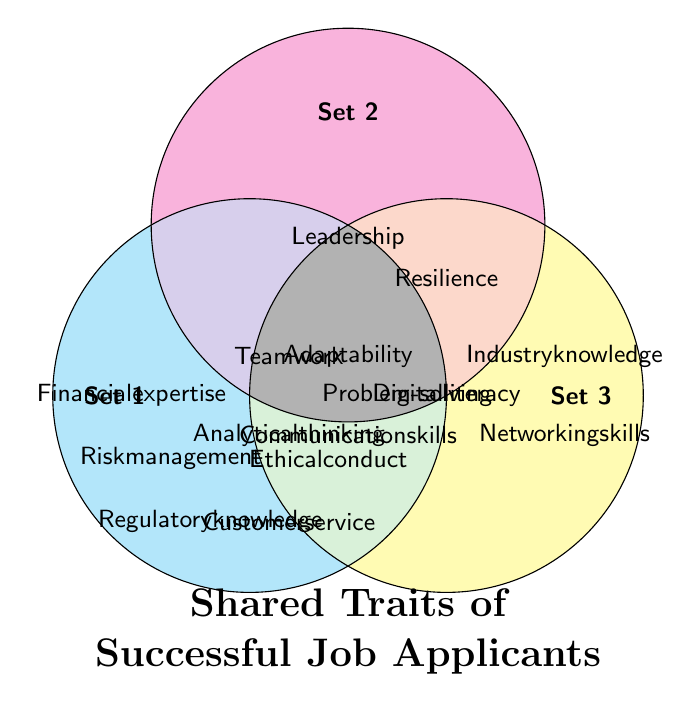What is the title of the Venn diagram? The title is located at the bottom center of the diagram and reads "Shared Traits of Successful Job Applicants"
Answer: Shared Traits of Successful Job Applicants How many sets are represented in the Venn diagram? By observing the circles marked with headers, you can see that there are three distinct sets labeled "Set 1", "Set 2", and "Set 3"
Answer: 3 Which traits are common to all three sets? The traits common to all three sets are at the intersection point of all three circles, indicated as "Adaptability," "Communication skills," "Problem-solving," "Teamwork," and "Analytical thinking."
Answer: Adaptability, Communication skills, Problem-solving, Teamwork, Analytical thinking What traits are unique to Set 1? Traits unique to Set 1 are those only within the leftmost circle and are not intersected by other circles. These are "Financial expertise," "Risk management," "Regulatory knowledge," "Customer service," and "Ethical conduct."
Answer: Financial expertise, Risk management, Regulatory knowledge, Customer service, Ethical conduct Which shared trait is found between Set 2 and Set 3 but not in Set 1? At the intersection between Set 2 and Set 3 and outside Set 1, you find "Digital literacy,"
Answer: Digital literacy How many traits does Set 2 share with Set 3? Identify the intersection of Set 2 and Set 3. The shared traits are "Communication skills," "Problem-solving," "Teamwork," "Analytical thinking," "Digital literacy," and "Resilience"
Answer: 6 How many traits are exclusive to Set 3? Traits exclusive to Set 3 are those within its circle but outside the intersections with the other circles, which are "Industry knowledge" and "Networking skills."
Answer: 2 Which of the sets includes "Communication skills"? By examining the positions of "Communication skills," you can see it's at the intersection of all three sets, thus included in Set 1, Set 2, and Set 3
Answer: Set 1, Set 2, Set 3 